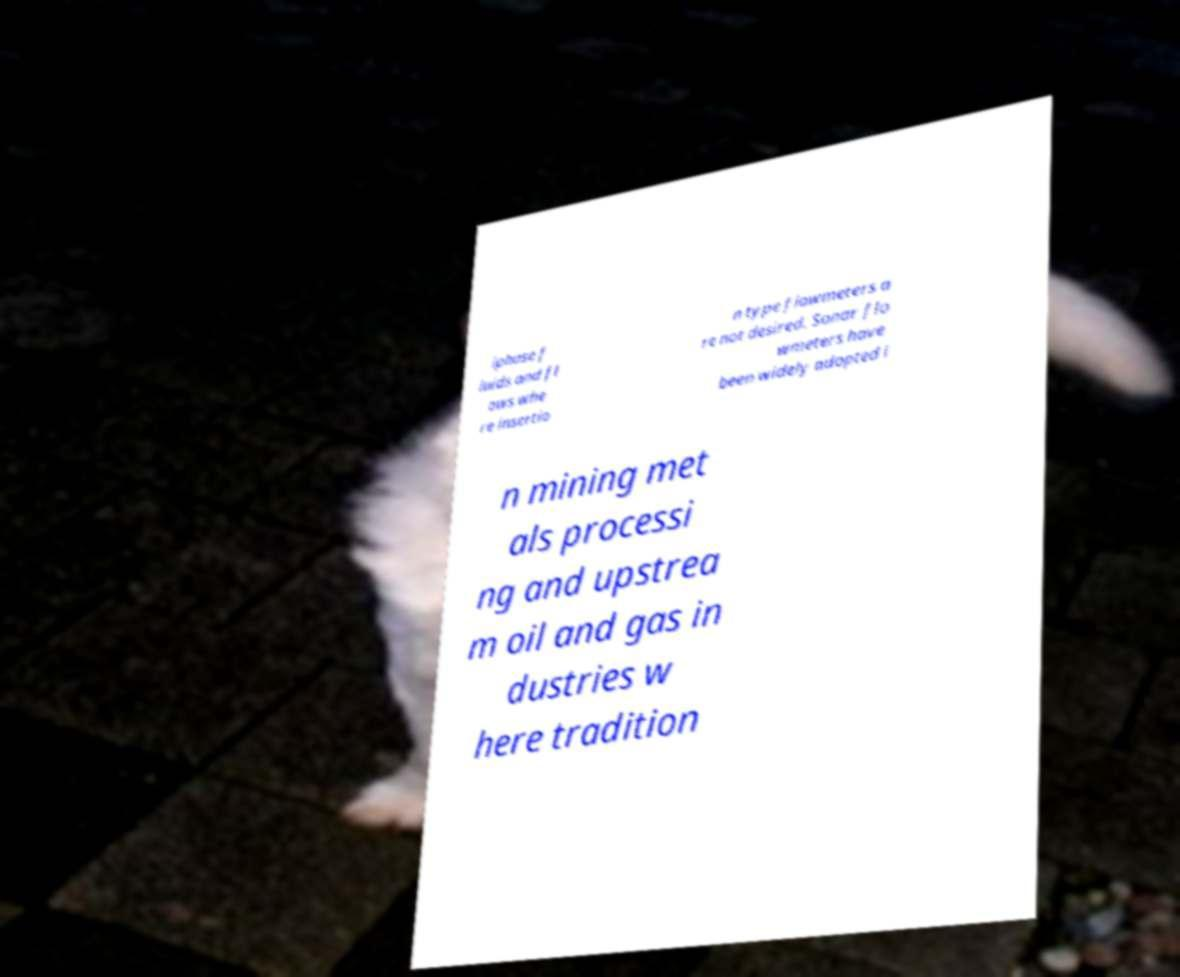What messages or text are displayed in this image? I need them in a readable, typed format. iphase f luids and fl ows whe re insertio n type flowmeters a re not desired. Sonar flo wmeters have been widely adopted i n mining met als processi ng and upstrea m oil and gas in dustries w here tradition 